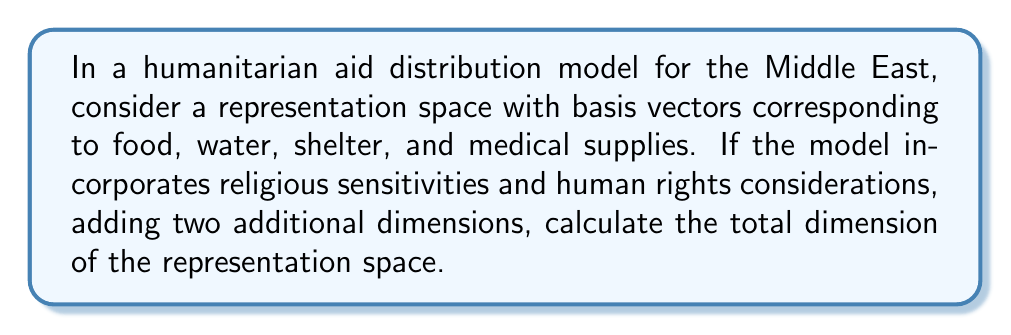Can you solve this math problem? Let's approach this step-by-step:

1) First, we identify the initial basis vectors of the representation space:
   - Food
   - Water
   - Shelter
   - Medical supplies

   These form a 4-dimensional space: $\dim V_1 = 4$

2) The model incorporates two additional dimensions:
   - Religious sensitivities
   - Human rights considerations

   These add 2 more dimensions: $\dim V_2 = 2$

3) The total dimension of the representation space is the sum of these subspaces:

   $$\dim V_{total} = \dim V_1 + \dim V_2$$

4) Substituting the values:

   $$\dim V_{total} = 4 + 2 = 6$$

Therefore, the total dimension of the representation space for this humanitarian aid distribution model is 6.
Answer: 6 